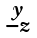Convert formula to latex. <formula><loc_0><loc_0><loc_500><loc_500>\begin{smallmatrix} y \\ - z \end{smallmatrix}</formula> 